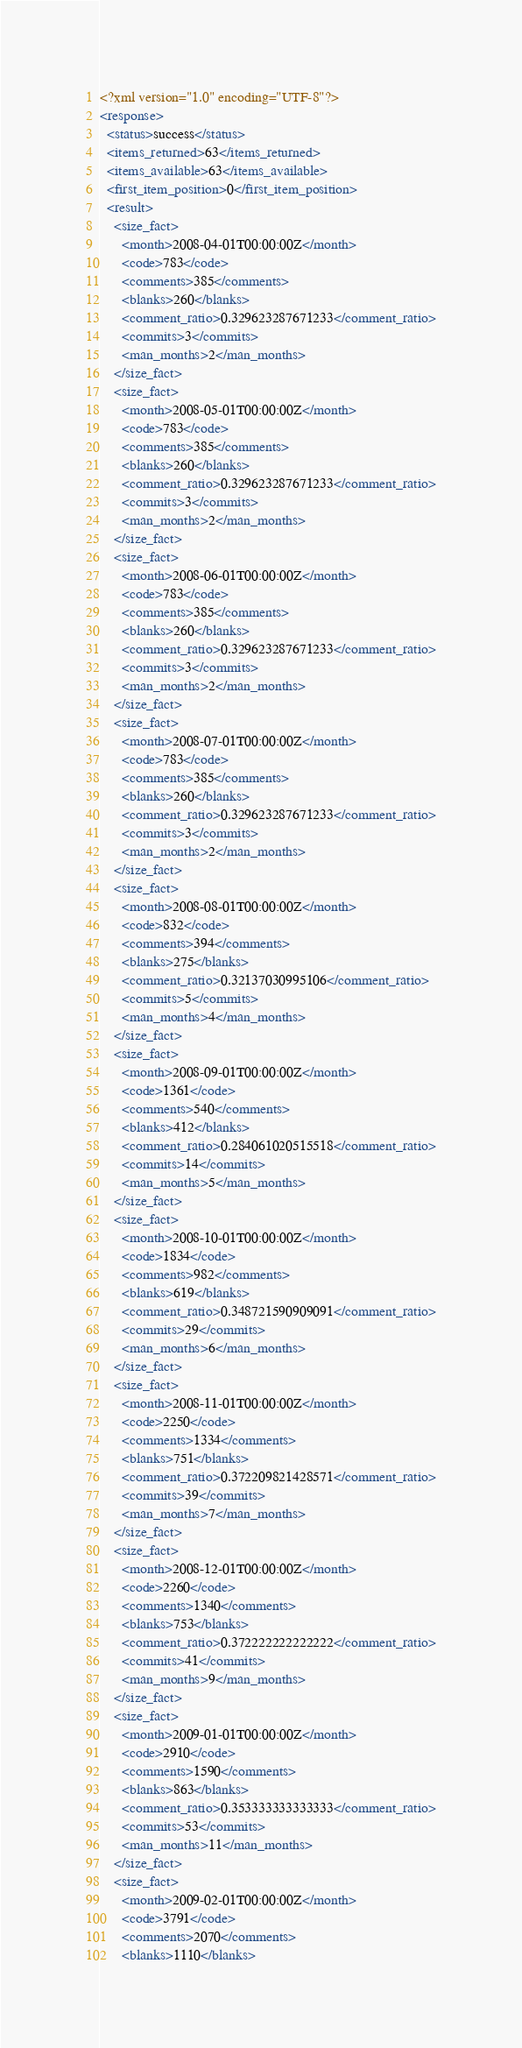<code> <loc_0><loc_0><loc_500><loc_500><_XML_><?xml version="1.0" encoding="UTF-8"?>
<response>
  <status>success</status>
  <items_returned>63</items_returned>
  <items_available>63</items_available>
  <first_item_position>0</first_item_position>
  <result>
    <size_fact>
      <month>2008-04-01T00:00:00Z</month>
      <code>783</code>
      <comments>385</comments>
      <blanks>260</blanks>
      <comment_ratio>0.329623287671233</comment_ratio>
      <commits>3</commits>
      <man_months>2</man_months>
    </size_fact>
    <size_fact>
      <month>2008-05-01T00:00:00Z</month>
      <code>783</code>
      <comments>385</comments>
      <blanks>260</blanks>
      <comment_ratio>0.329623287671233</comment_ratio>
      <commits>3</commits>
      <man_months>2</man_months>
    </size_fact>
    <size_fact>
      <month>2008-06-01T00:00:00Z</month>
      <code>783</code>
      <comments>385</comments>
      <blanks>260</blanks>
      <comment_ratio>0.329623287671233</comment_ratio>
      <commits>3</commits>
      <man_months>2</man_months>
    </size_fact>
    <size_fact>
      <month>2008-07-01T00:00:00Z</month>
      <code>783</code>
      <comments>385</comments>
      <blanks>260</blanks>
      <comment_ratio>0.329623287671233</comment_ratio>
      <commits>3</commits>
      <man_months>2</man_months>
    </size_fact>
    <size_fact>
      <month>2008-08-01T00:00:00Z</month>
      <code>832</code>
      <comments>394</comments>
      <blanks>275</blanks>
      <comment_ratio>0.32137030995106</comment_ratio>
      <commits>5</commits>
      <man_months>4</man_months>
    </size_fact>
    <size_fact>
      <month>2008-09-01T00:00:00Z</month>
      <code>1361</code>
      <comments>540</comments>
      <blanks>412</blanks>
      <comment_ratio>0.284061020515518</comment_ratio>
      <commits>14</commits>
      <man_months>5</man_months>
    </size_fact>
    <size_fact>
      <month>2008-10-01T00:00:00Z</month>
      <code>1834</code>
      <comments>982</comments>
      <blanks>619</blanks>
      <comment_ratio>0.348721590909091</comment_ratio>
      <commits>29</commits>
      <man_months>6</man_months>
    </size_fact>
    <size_fact>
      <month>2008-11-01T00:00:00Z</month>
      <code>2250</code>
      <comments>1334</comments>
      <blanks>751</blanks>
      <comment_ratio>0.372209821428571</comment_ratio>
      <commits>39</commits>
      <man_months>7</man_months>
    </size_fact>
    <size_fact>
      <month>2008-12-01T00:00:00Z</month>
      <code>2260</code>
      <comments>1340</comments>
      <blanks>753</blanks>
      <comment_ratio>0.372222222222222</comment_ratio>
      <commits>41</commits>
      <man_months>9</man_months>
    </size_fact>
    <size_fact>
      <month>2009-01-01T00:00:00Z</month>
      <code>2910</code>
      <comments>1590</comments>
      <blanks>863</blanks>
      <comment_ratio>0.353333333333333</comment_ratio>
      <commits>53</commits>
      <man_months>11</man_months>
    </size_fact>
    <size_fact>
      <month>2009-02-01T00:00:00Z</month>
      <code>3791</code>
      <comments>2070</comments>
      <blanks>1110</blanks></code> 